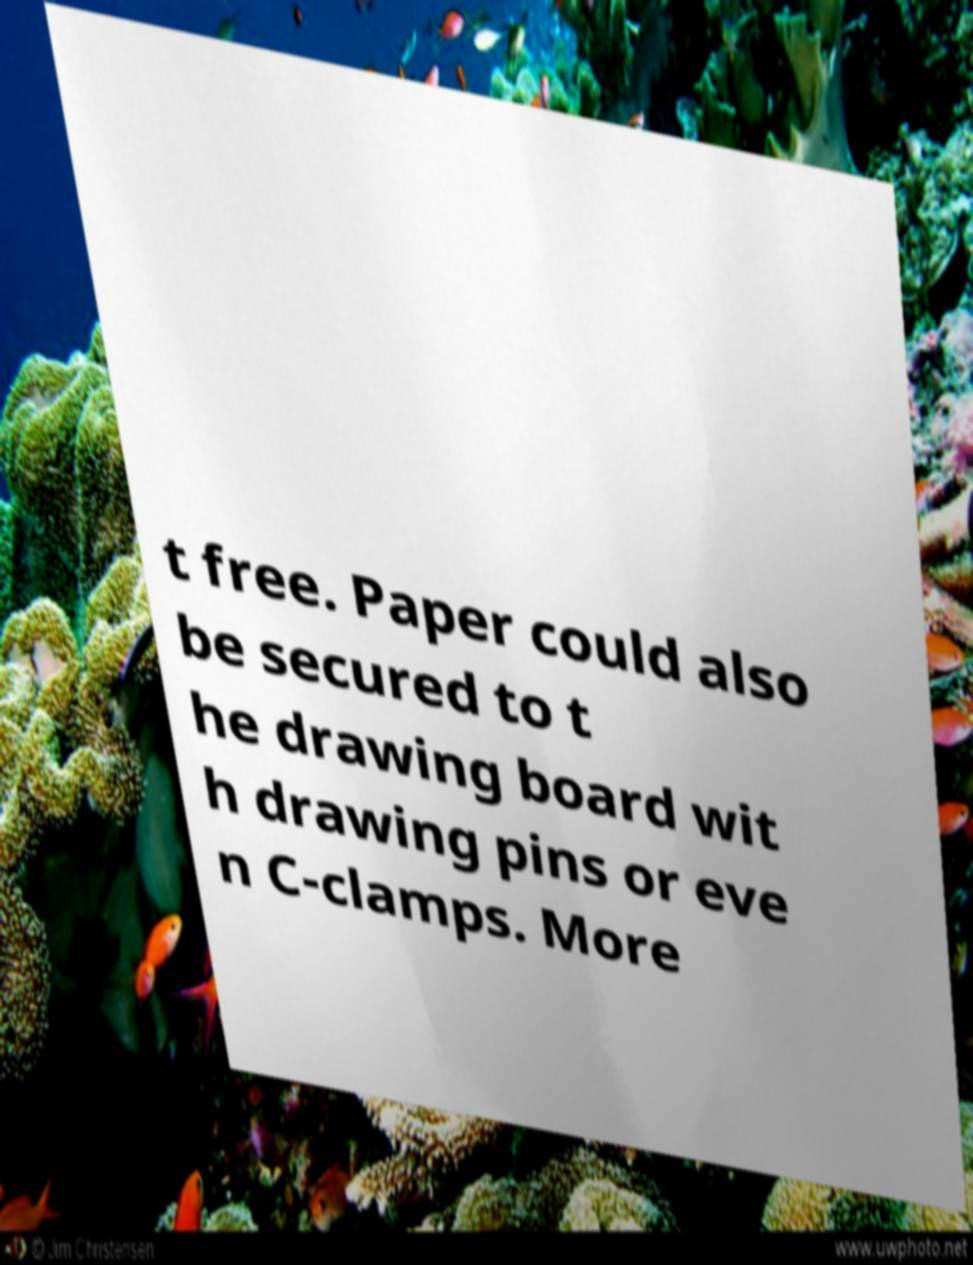For documentation purposes, I need the text within this image transcribed. Could you provide that? t free. Paper could also be secured to t he drawing board wit h drawing pins or eve n C-clamps. More 